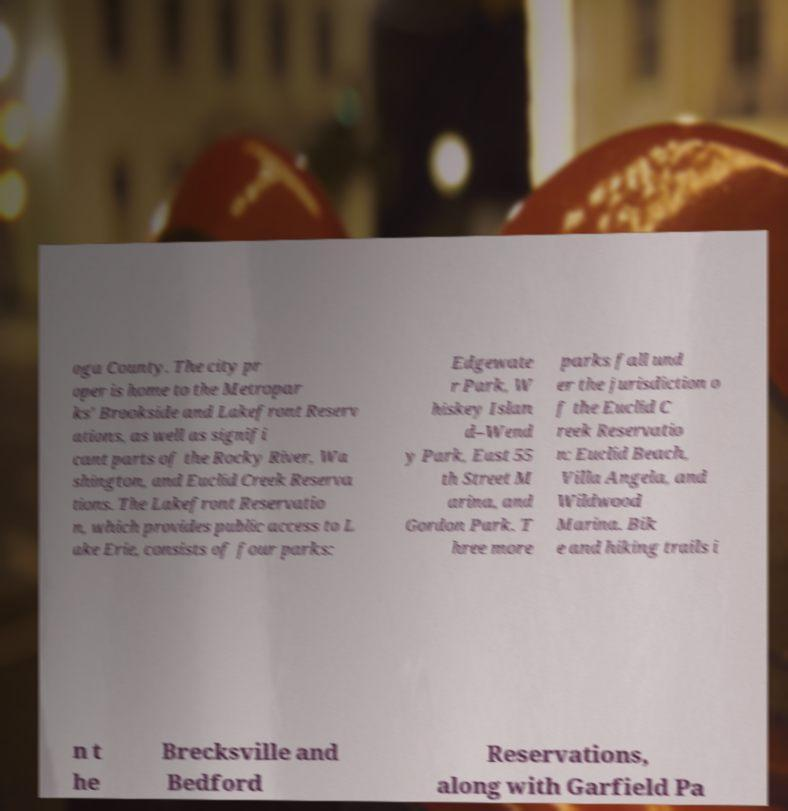I need the written content from this picture converted into text. Can you do that? oga County. The city pr oper is home to the Metropar ks' Brookside and Lakefront Reserv ations, as well as signifi cant parts of the Rocky River, Wa shington, and Euclid Creek Reserva tions. The Lakefront Reservatio n, which provides public access to L ake Erie, consists of four parks: Edgewate r Park, W hiskey Islan d–Wend y Park, East 55 th Street M arina, and Gordon Park. T hree more parks fall und er the jurisdiction o f the Euclid C reek Reservatio n: Euclid Beach, Villa Angela, and Wildwood Marina. Bik e and hiking trails i n t he Brecksville and Bedford Reservations, along with Garfield Pa 